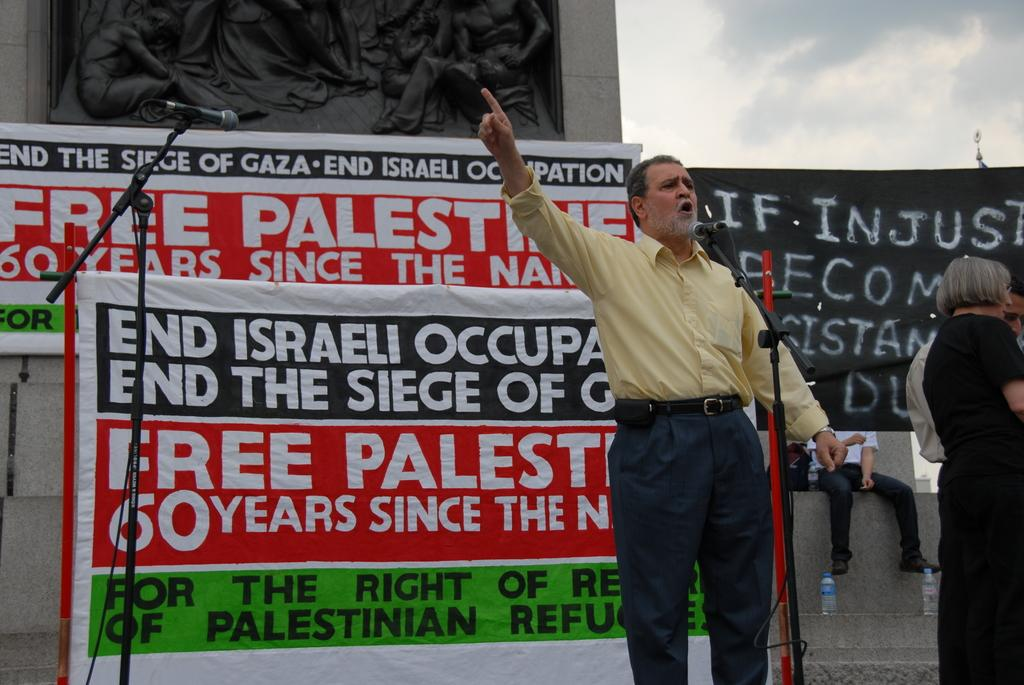What is happening in the image involving the people? There are people standing in the image, and a man is talking. What objects are present to aid in the man's talking? Microphones with stands are visible in the image. What can be seen in the background of the image? Banners and bottles are visible in the background of the image. Can you describe the seating arrangement in the image? There is a person sitting in the background of the image. What type of frog is sitting on the man's shoulder in the image? There is no frog present in the image; the man is talking without any frog on his shoulder. 